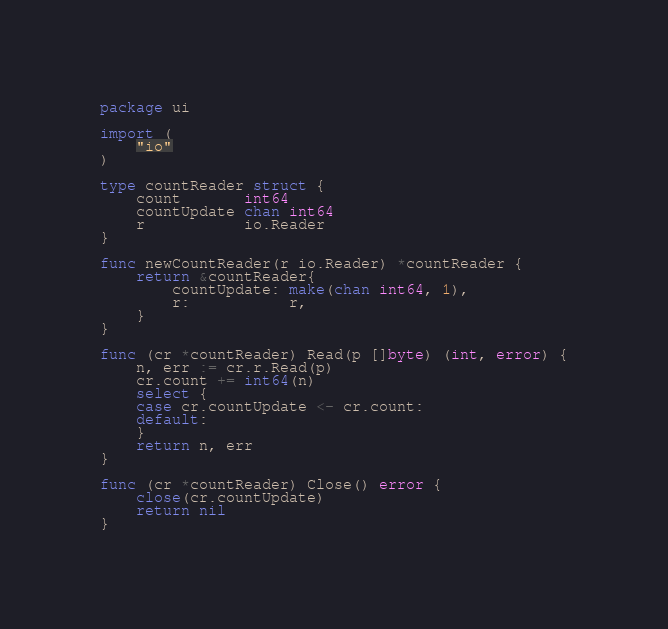Convert code to text. <code><loc_0><loc_0><loc_500><loc_500><_Go_>package ui

import (
	"io"
)

type countReader struct {
	count       int64
	countUpdate chan int64
	r           io.Reader
}

func newCountReader(r io.Reader) *countReader {
	return &countReader{
		countUpdate: make(chan int64, 1),
		r:           r,
	}
}

func (cr *countReader) Read(p []byte) (int, error) {
	n, err := cr.r.Read(p)
	cr.count += int64(n)
	select {
	case cr.countUpdate <- cr.count:
	default:
	}
	return n, err
}

func (cr *countReader) Close() error {
	close(cr.countUpdate)
	return nil
}
</code> 